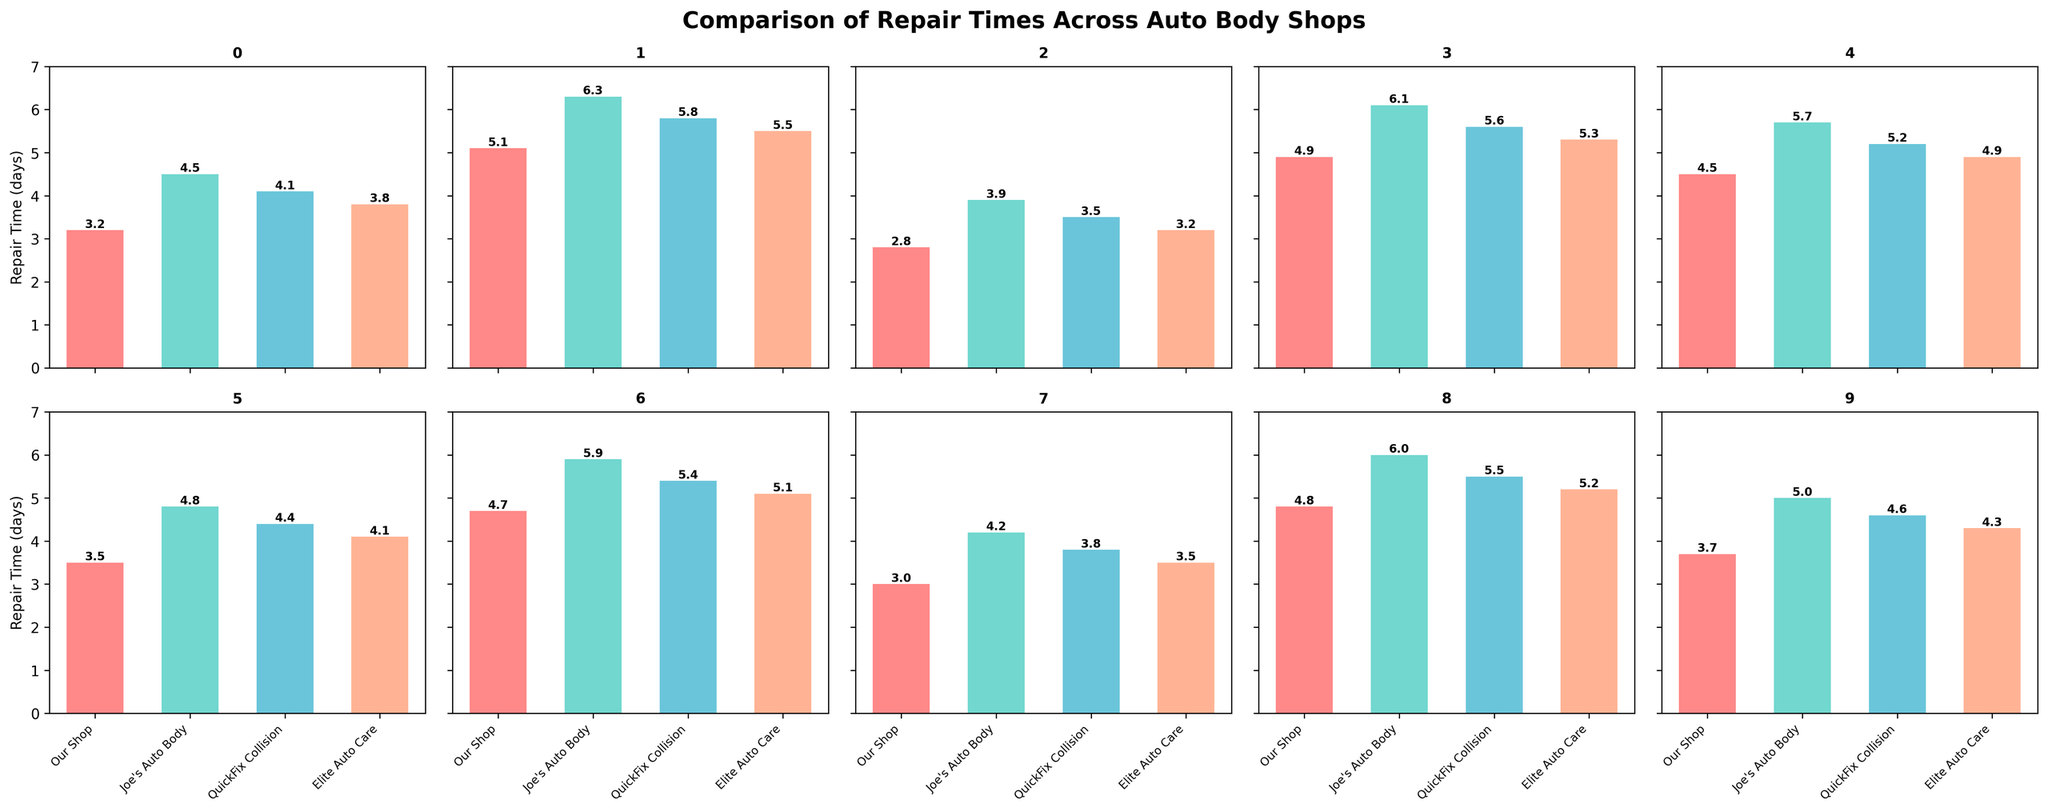How many car models are compared in the figure? Count the number of individual bar charts (subplots) in the grid. There are 10 subplots, each representing a different car model.
Answer: 10 Which auto body shop has the longest repair time for a Toyota Camry? Look at the subplot for the Toyota Camry and compare the heights of the bars. Joe's Auto Body has the tallest bar with a repair time of 4.5 days.
Answer: Joe's Auto Body What is the average repair time for a BMW 3 Series across all shops? Add the repair times for the BMW 3 Series from all shops (4.5 + 5.7 + 5.2 + 4.9) and then divide by the number of shops (4). The average is (4.5 + 5.7 + 5.2 + 4.9) / 4 = 5.075.
Answer: 5.075 Is there any car model where our shop has the shortest repair time? Scan each subplot to compare the bars across all auto body shops. For Toyota Camry, Honda Civic, Nissan Altima, Hyundai Elantra, and Mercedes-Benz C-Class, our shop has the shortest repair time.
Answer: Yes Which car model has the highest repair time overall and which shop is it? Find the maximum repair time in all subplots. The highest repair time is 6.3 days for the Ford F-150 at Joe's Auto Body.
Answer: Ford F-150 at Joe's Auto Body How does the repair time for the Subaru Outback at our shop compare to QuickFix Collision? Look at the Subaru Outback subplot and compare the heights of the bars for our shop and QuickFix Collision. Our shop has a repair time of 3.7 days, while QuickFix Collision has 4.6 days.
Answer: Our shop is faster What is the difference in repair times between our shop and Elite Auto Care for the Nissan Altima? Look at the repair times for the Nissan Altima in our shop and Elite Auto Care. The values are 3.5 and 4.1 days respectively. The difference is 4.1 - 3.5 = 0.6 days.
Answer: 0.6 days Which car model shows the least variation in repair times across all shops? Compare the range of repair times (difference between the highest and lowest values) for each car model. The Honda Civic has the least variation with repair times of 2.8 to 3.9 days.
Answer: Honda Civic Does any shop consistently have the longest repair times across multiple car models? Check each subplot to see if one shop frequently has the highest bars. Joe's Auto Body often has the longest repair times for several models like Toyota Camry, Ford F-150, Chevrolet Silverado, BMW 3 Series, and Mercedes-Benz C-Class.
Answer: Joe's Auto Body How does the repair time for the Jeep Wrangler at Elite Auto Care compare to the overall average repair time for the same model? Identify the repair time for Jeep Wrangler at Elite Auto Care (5.1 days). Calculate the overall average repair time for Jeep Wrangler by summing the repair times across all shops (4.7 + 5.9 + 5.4 + 5.1) and dividing by 4. The average is (4.7 + 5.9 + 5.4 + 5.1) / 4 = 5.275. Comparing 5.1 to 5.275 shows Elite Auto Care is slightly below the average.
Answer: Slightly below average 